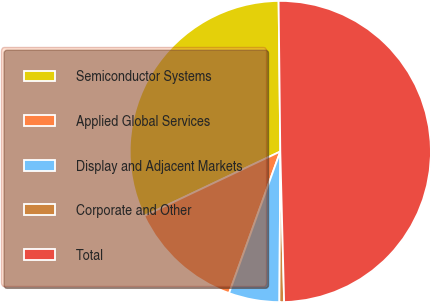<chart> <loc_0><loc_0><loc_500><loc_500><pie_chart><fcel>Semiconductor Systems<fcel>Applied Global Services<fcel>Display and Adjacent Markets<fcel>Corporate and Other<fcel>Total<nl><fcel>31.86%<fcel>12.44%<fcel>5.43%<fcel>0.5%<fcel>49.78%<nl></chart> 